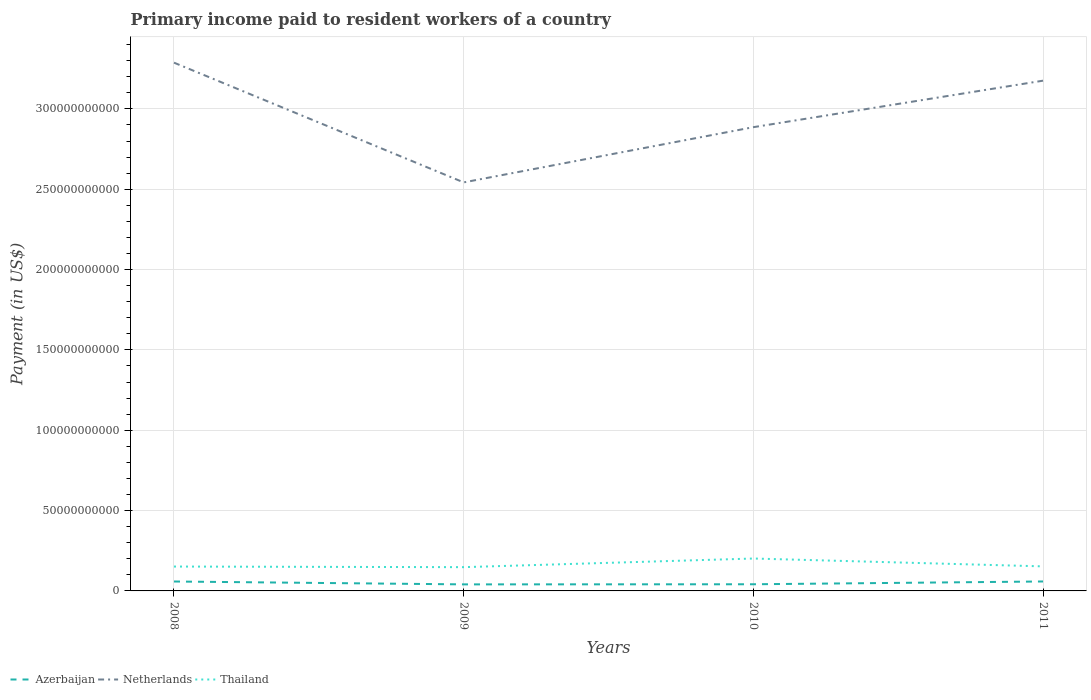How many different coloured lines are there?
Make the answer very short. 3. Does the line corresponding to Azerbaijan intersect with the line corresponding to Netherlands?
Provide a short and direct response. No. Across all years, what is the maximum amount paid to workers in Azerbaijan?
Provide a succinct answer. 4.07e+09. In which year was the amount paid to workers in Thailand maximum?
Offer a very short reply. 2009. What is the total amount paid to workers in Thailand in the graph?
Ensure brevity in your answer.  -5.38e+09. What is the difference between the highest and the second highest amount paid to workers in Thailand?
Make the answer very short. 5.38e+09. How many lines are there?
Provide a succinct answer. 3. How many years are there in the graph?
Offer a terse response. 4. Does the graph contain grids?
Give a very brief answer. Yes. What is the title of the graph?
Keep it short and to the point. Primary income paid to resident workers of a country. What is the label or title of the Y-axis?
Ensure brevity in your answer.  Payment (in US$). What is the Payment (in US$) in Azerbaijan in 2008?
Your response must be concise. 5.86e+09. What is the Payment (in US$) in Netherlands in 2008?
Your response must be concise. 3.29e+11. What is the Payment (in US$) in Thailand in 2008?
Provide a short and direct response. 1.52e+1. What is the Payment (in US$) of Azerbaijan in 2009?
Give a very brief answer. 4.07e+09. What is the Payment (in US$) in Netherlands in 2009?
Provide a short and direct response. 2.54e+11. What is the Payment (in US$) in Thailand in 2009?
Offer a very short reply. 1.48e+1. What is the Payment (in US$) of Azerbaijan in 2010?
Your answer should be very brief. 4.14e+09. What is the Payment (in US$) in Netherlands in 2010?
Ensure brevity in your answer.  2.89e+11. What is the Payment (in US$) of Thailand in 2010?
Keep it short and to the point. 2.02e+1. What is the Payment (in US$) of Azerbaijan in 2011?
Give a very brief answer. 5.88e+09. What is the Payment (in US$) of Netherlands in 2011?
Offer a terse response. 3.18e+11. What is the Payment (in US$) in Thailand in 2011?
Your answer should be compact. 1.53e+1. Across all years, what is the maximum Payment (in US$) in Azerbaijan?
Provide a succinct answer. 5.88e+09. Across all years, what is the maximum Payment (in US$) in Netherlands?
Ensure brevity in your answer.  3.29e+11. Across all years, what is the maximum Payment (in US$) in Thailand?
Make the answer very short. 2.02e+1. Across all years, what is the minimum Payment (in US$) of Azerbaijan?
Keep it short and to the point. 4.07e+09. Across all years, what is the minimum Payment (in US$) in Netherlands?
Your response must be concise. 2.54e+11. Across all years, what is the minimum Payment (in US$) in Thailand?
Ensure brevity in your answer.  1.48e+1. What is the total Payment (in US$) of Azerbaijan in the graph?
Offer a very short reply. 2.00e+1. What is the total Payment (in US$) in Netherlands in the graph?
Offer a very short reply. 1.19e+12. What is the total Payment (in US$) of Thailand in the graph?
Keep it short and to the point. 6.54e+1. What is the difference between the Payment (in US$) of Azerbaijan in 2008 and that in 2009?
Your answer should be very brief. 1.79e+09. What is the difference between the Payment (in US$) of Netherlands in 2008 and that in 2009?
Provide a succinct answer. 7.45e+1. What is the difference between the Payment (in US$) of Thailand in 2008 and that in 2009?
Provide a short and direct response. 3.81e+08. What is the difference between the Payment (in US$) of Azerbaijan in 2008 and that in 2010?
Your response must be concise. 1.72e+09. What is the difference between the Payment (in US$) in Netherlands in 2008 and that in 2010?
Provide a succinct answer. 4.01e+1. What is the difference between the Payment (in US$) of Thailand in 2008 and that in 2010?
Give a very brief answer. -5.00e+09. What is the difference between the Payment (in US$) in Azerbaijan in 2008 and that in 2011?
Give a very brief answer. -1.74e+07. What is the difference between the Payment (in US$) in Netherlands in 2008 and that in 2011?
Offer a very short reply. 1.12e+1. What is the difference between the Payment (in US$) of Thailand in 2008 and that in 2011?
Make the answer very short. -1.02e+08. What is the difference between the Payment (in US$) of Azerbaijan in 2009 and that in 2010?
Your response must be concise. -7.20e+07. What is the difference between the Payment (in US$) of Netherlands in 2009 and that in 2010?
Your answer should be very brief. -3.44e+1. What is the difference between the Payment (in US$) of Thailand in 2009 and that in 2010?
Your answer should be compact. -5.38e+09. What is the difference between the Payment (in US$) of Azerbaijan in 2009 and that in 2011?
Your answer should be very brief. -1.81e+09. What is the difference between the Payment (in US$) of Netherlands in 2009 and that in 2011?
Ensure brevity in your answer.  -6.33e+1. What is the difference between the Payment (in US$) of Thailand in 2009 and that in 2011?
Offer a terse response. -4.83e+08. What is the difference between the Payment (in US$) in Azerbaijan in 2010 and that in 2011?
Your answer should be compact. -1.74e+09. What is the difference between the Payment (in US$) in Netherlands in 2010 and that in 2011?
Offer a terse response. -2.89e+1. What is the difference between the Payment (in US$) of Thailand in 2010 and that in 2011?
Keep it short and to the point. 4.89e+09. What is the difference between the Payment (in US$) of Azerbaijan in 2008 and the Payment (in US$) of Netherlands in 2009?
Keep it short and to the point. -2.48e+11. What is the difference between the Payment (in US$) in Azerbaijan in 2008 and the Payment (in US$) in Thailand in 2009?
Give a very brief answer. -8.93e+09. What is the difference between the Payment (in US$) in Netherlands in 2008 and the Payment (in US$) in Thailand in 2009?
Offer a terse response. 3.14e+11. What is the difference between the Payment (in US$) in Azerbaijan in 2008 and the Payment (in US$) in Netherlands in 2010?
Your answer should be very brief. -2.83e+11. What is the difference between the Payment (in US$) of Azerbaijan in 2008 and the Payment (in US$) of Thailand in 2010?
Your answer should be very brief. -1.43e+1. What is the difference between the Payment (in US$) in Netherlands in 2008 and the Payment (in US$) in Thailand in 2010?
Your answer should be very brief. 3.09e+11. What is the difference between the Payment (in US$) in Azerbaijan in 2008 and the Payment (in US$) in Netherlands in 2011?
Your answer should be very brief. -3.12e+11. What is the difference between the Payment (in US$) of Azerbaijan in 2008 and the Payment (in US$) of Thailand in 2011?
Offer a very short reply. -9.41e+09. What is the difference between the Payment (in US$) of Netherlands in 2008 and the Payment (in US$) of Thailand in 2011?
Provide a succinct answer. 3.13e+11. What is the difference between the Payment (in US$) of Azerbaijan in 2009 and the Payment (in US$) of Netherlands in 2010?
Make the answer very short. -2.85e+11. What is the difference between the Payment (in US$) in Azerbaijan in 2009 and the Payment (in US$) in Thailand in 2010?
Ensure brevity in your answer.  -1.61e+1. What is the difference between the Payment (in US$) of Netherlands in 2009 and the Payment (in US$) of Thailand in 2010?
Your answer should be very brief. 2.34e+11. What is the difference between the Payment (in US$) of Azerbaijan in 2009 and the Payment (in US$) of Netherlands in 2011?
Offer a terse response. -3.13e+11. What is the difference between the Payment (in US$) in Azerbaijan in 2009 and the Payment (in US$) in Thailand in 2011?
Give a very brief answer. -1.12e+1. What is the difference between the Payment (in US$) of Netherlands in 2009 and the Payment (in US$) of Thailand in 2011?
Your response must be concise. 2.39e+11. What is the difference between the Payment (in US$) in Azerbaijan in 2010 and the Payment (in US$) in Netherlands in 2011?
Ensure brevity in your answer.  -3.13e+11. What is the difference between the Payment (in US$) of Azerbaijan in 2010 and the Payment (in US$) of Thailand in 2011?
Your response must be concise. -1.11e+1. What is the difference between the Payment (in US$) in Netherlands in 2010 and the Payment (in US$) in Thailand in 2011?
Your response must be concise. 2.73e+11. What is the average Payment (in US$) in Azerbaijan per year?
Keep it short and to the point. 4.99e+09. What is the average Payment (in US$) of Netherlands per year?
Your response must be concise. 2.97e+11. What is the average Payment (in US$) of Thailand per year?
Your answer should be compact. 1.64e+1. In the year 2008, what is the difference between the Payment (in US$) of Azerbaijan and Payment (in US$) of Netherlands?
Provide a succinct answer. -3.23e+11. In the year 2008, what is the difference between the Payment (in US$) of Azerbaijan and Payment (in US$) of Thailand?
Give a very brief answer. -9.31e+09. In the year 2008, what is the difference between the Payment (in US$) in Netherlands and Payment (in US$) in Thailand?
Provide a succinct answer. 3.14e+11. In the year 2009, what is the difference between the Payment (in US$) of Azerbaijan and Payment (in US$) of Netherlands?
Make the answer very short. -2.50e+11. In the year 2009, what is the difference between the Payment (in US$) in Azerbaijan and Payment (in US$) in Thailand?
Your response must be concise. -1.07e+1. In the year 2009, what is the difference between the Payment (in US$) in Netherlands and Payment (in US$) in Thailand?
Ensure brevity in your answer.  2.39e+11. In the year 2010, what is the difference between the Payment (in US$) of Azerbaijan and Payment (in US$) of Netherlands?
Ensure brevity in your answer.  -2.84e+11. In the year 2010, what is the difference between the Payment (in US$) in Azerbaijan and Payment (in US$) in Thailand?
Your response must be concise. -1.60e+1. In the year 2010, what is the difference between the Payment (in US$) in Netherlands and Payment (in US$) in Thailand?
Your answer should be compact. 2.68e+11. In the year 2011, what is the difference between the Payment (in US$) in Azerbaijan and Payment (in US$) in Netherlands?
Your answer should be compact. -3.12e+11. In the year 2011, what is the difference between the Payment (in US$) in Azerbaijan and Payment (in US$) in Thailand?
Your answer should be compact. -9.39e+09. In the year 2011, what is the difference between the Payment (in US$) of Netherlands and Payment (in US$) of Thailand?
Provide a short and direct response. 3.02e+11. What is the ratio of the Payment (in US$) of Azerbaijan in 2008 to that in 2009?
Offer a very short reply. 1.44. What is the ratio of the Payment (in US$) of Netherlands in 2008 to that in 2009?
Keep it short and to the point. 1.29. What is the ratio of the Payment (in US$) of Thailand in 2008 to that in 2009?
Offer a terse response. 1.03. What is the ratio of the Payment (in US$) of Azerbaijan in 2008 to that in 2010?
Make the answer very short. 1.41. What is the ratio of the Payment (in US$) in Netherlands in 2008 to that in 2010?
Offer a very short reply. 1.14. What is the ratio of the Payment (in US$) of Thailand in 2008 to that in 2010?
Offer a terse response. 0.75. What is the ratio of the Payment (in US$) of Netherlands in 2008 to that in 2011?
Offer a terse response. 1.04. What is the ratio of the Payment (in US$) in Azerbaijan in 2009 to that in 2010?
Keep it short and to the point. 0.98. What is the ratio of the Payment (in US$) of Netherlands in 2009 to that in 2010?
Make the answer very short. 0.88. What is the ratio of the Payment (in US$) in Thailand in 2009 to that in 2010?
Provide a succinct answer. 0.73. What is the ratio of the Payment (in US$) of Azerbaijan in 2009 to that in 2011?
Give a very brief answer. 0.69. What is the ratio of the Payment (in US$) in Netherlands in 2009 to that in 2011?
Make the answer very short. 0.8. What is the ratio of the Payment (in US$) in Thailand in 2009 to that in 2011?
Make the answer very short. 0.97. What is the ratio of the Payment (in US$) in Azerbaijan in 2010 to that in 2011?
Make the answer very short. 0.7. What is the ratio of the Payment (in US$) of Netherlands in 2010 to that in 2011?
Your response must be concise. 0.91. What is the ratio of the Payment (in US$) of Thailand in 2010 to that in 2011?
Provide a succinct answer. 1.32. What is the difference between the highest and the second highest Payment (in US$) of Azerbaijan?
Provide a short and direct response. 1.74e+07. What is the difference between the highest and the second highest Payment (in US$) in Netherlands?
Your response must be concise. 1.12e+1. What is the difference between the highest and the second highest Payment (in US$) in Thailand?
Ensure brevity in your answer.  4.89e+09. What is the difference between the highest and the lowest Payment (in US$) in Azerbaijan?
Provide a short and direct response. 1.81e+09. What is the difference between the highest and the lowest Payment (in US$) of Netherlands?
Offer a terse response. 7.45e+1. What is the difference between the highest and the lowest Payment (in US$) in Thailand?
Provide a short and direct response. 5.38e+09. 